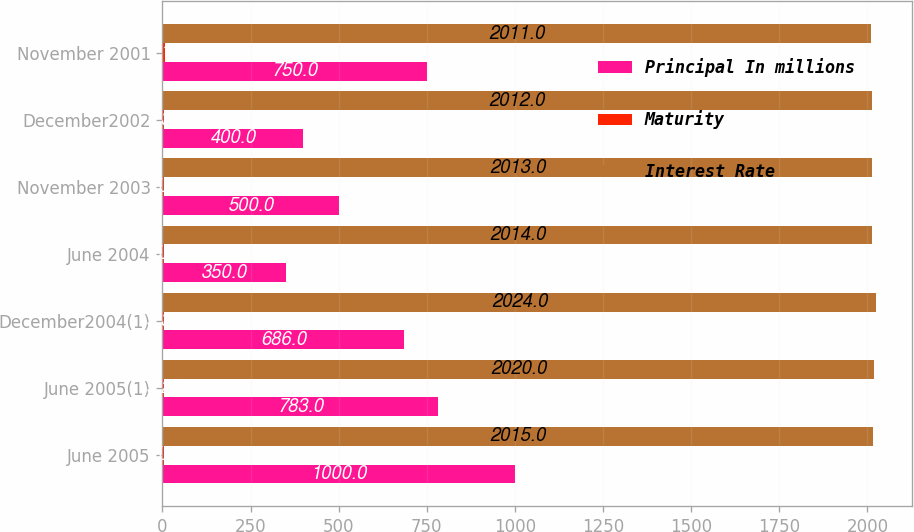Convert chart. <chart><loc_0><loc_0><loc_500><loc_500><stacked_bar_chart><ecel><fcel>June 2005<fcel>June 2005(1)<fcel>December2004(1)<fcel>June 2004<fcel>November 2003<fcel>December2002<fcel>November 2001<nl><fcel>Principal In millions<fcel>1000<fcel>783<fcel>686<fcel>350<fcel>500<fcel>400<fcel>750<nl><fcel>Maturity<fcel>5<fcel>5.25<fcel>5.38<fcel>5.5<fcel>5<fcel>5.38<fcel>6.13<nl><fcel>Interest Rate<fcel>2015<fcel>2020<fcel>2024<fcel>2014<fcel>2013<fcel>2012<fcel>2011<nl></chart> 